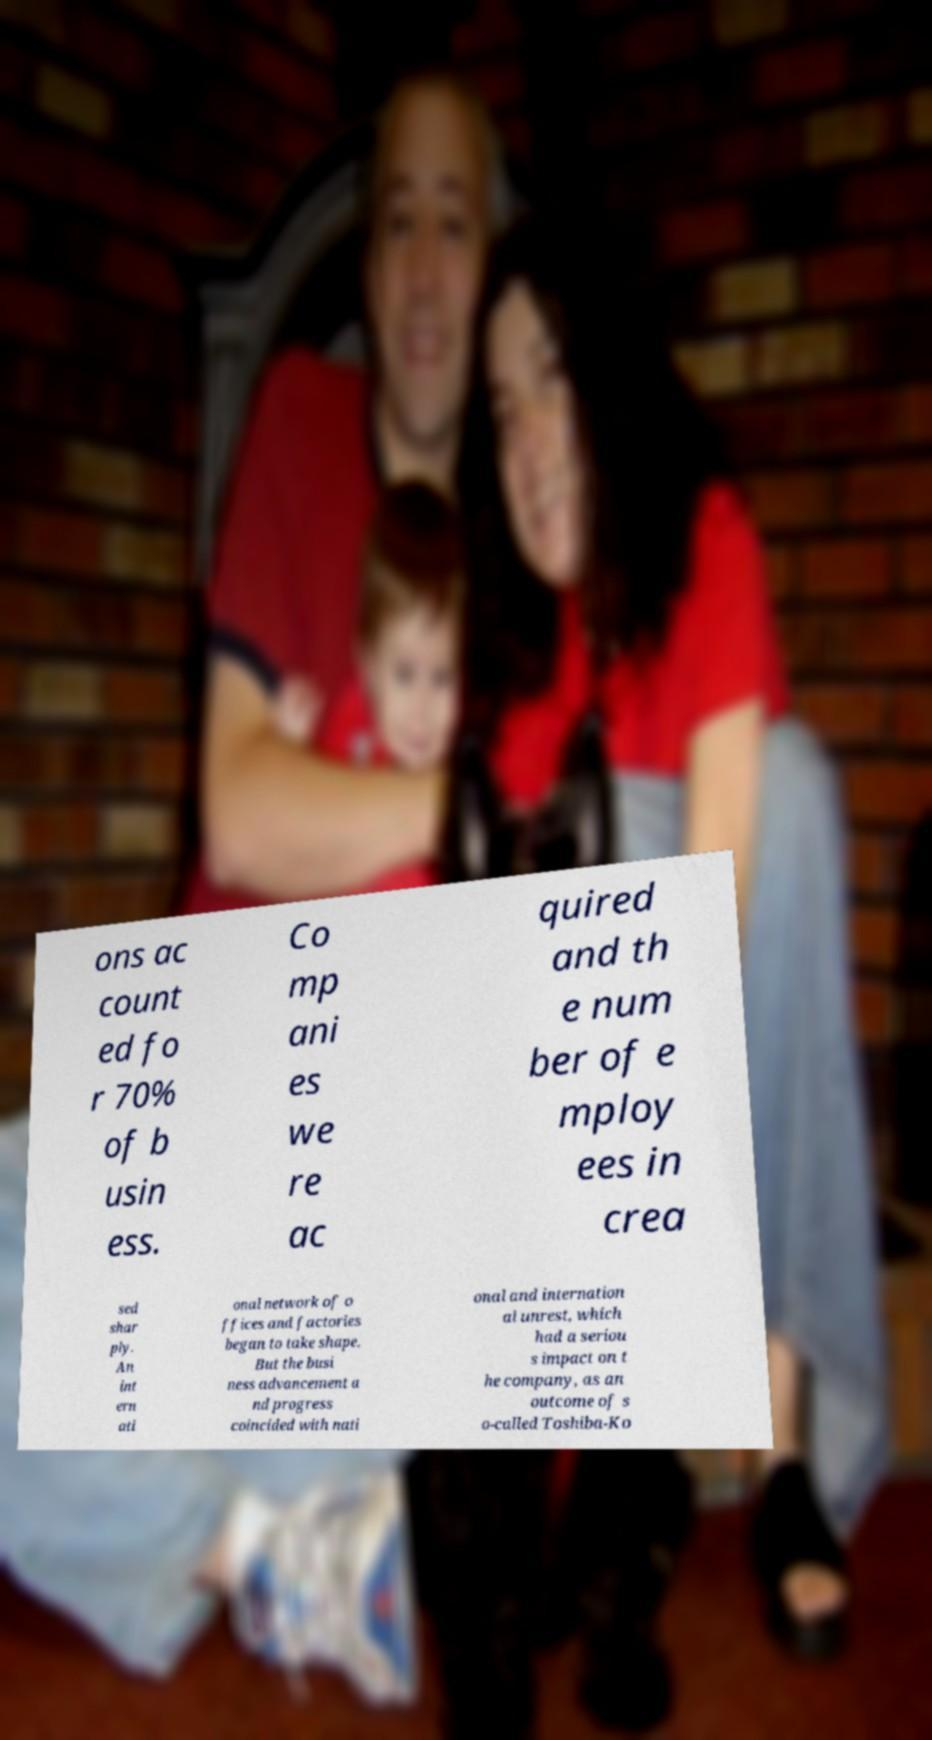There's text embedded in this image that I need extracted. Can you transcribe it verbatim? ons ac count ed fo r 70% of b usin ess. Co mp ani es we re ac quired and th e num ber of e mploy ees in crea sed shar ply. An int ern ati onal network of o ffices and factories began to take shape. But the busi ness advancement a nd progress coincided with nati onal and internation al unrest, which had a seriou s impact on t he company, as an outcome of s o-called Toshiba-Ko 